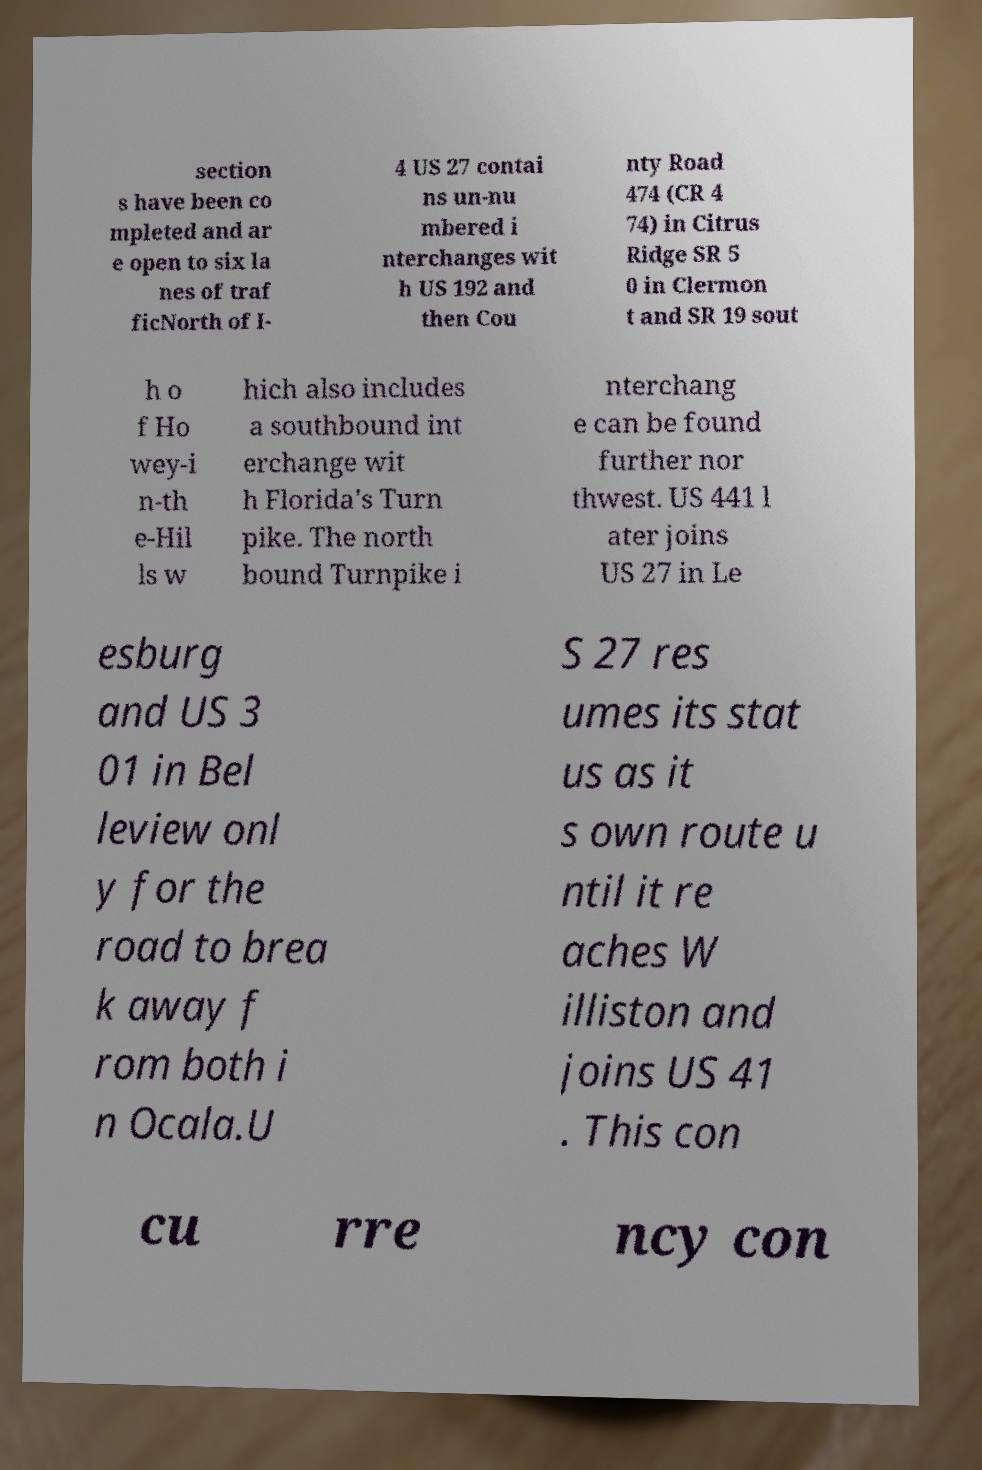For documentation purposes, I need the text within this image transcribed. Could you provide that? section s have been co mpleted and ar e open to six la nes of traf ficNorth of I- 4 US 27 contai ns un-nu mbered i nterchanges wit h US 192 and then Cou nty Road 474 (CR 4 74) in Citrus Ridge SR 5 0 in Clermon t and SR 19 sout h o f Ho wey-i n-th e-Hil ls w hich also includes a southbound int erchange wit h Florida's Turn pike. The north bound Turnpike i nterchang e can be found further nor thwest. US 441 l ater joins US 27 in Le esburg and US 3 01 in Bel leview onl y for the road to brea k away f rom both i n Ocala.U S 27 res umes its stat us as it s own route u ntil it re aches W illiston and joins US 41 . This con cu rre ncy con 